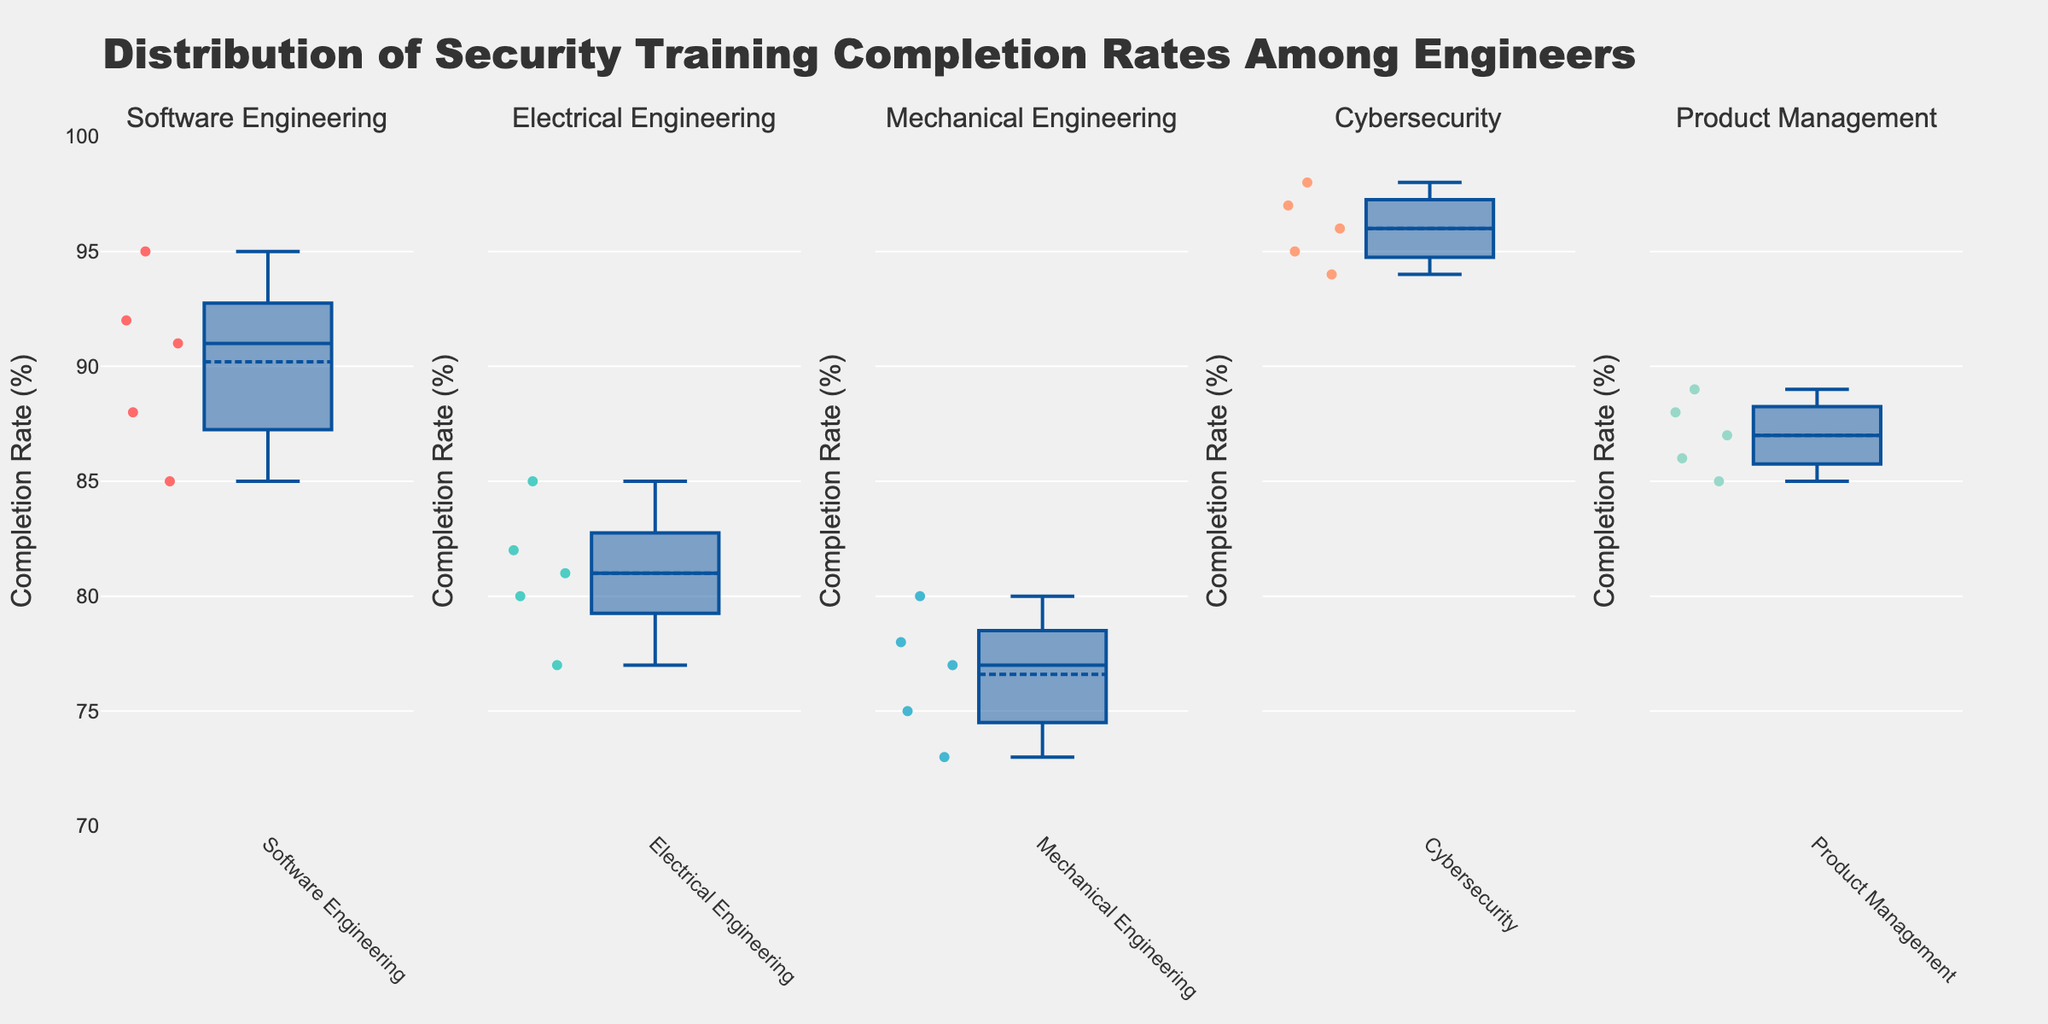What's the title of the plot? The title is displayed at the top of the figure and reads "Distribution of Security Training Completion Rates Among Engineers".
Answer: Distribution of Security Training Completion Rates Among Engineers What is the y-axis label? The y-axis label is located on the left side of the figure and it reads "Completion Rate (%)".
Answer: Completion Rate (%) How many departments are represented in the figure? There are 5 subplots, each representing a different department. The subplot titles are the department names.
Answer: 5 Which department has the highest median security training completion rate? The median value can be identified by the line inside the box of each subplot. The department with the highest median line is Cybersecurity.
Answer: Cybersecurity Which department shows the greatest variability in security training completion rates? Variability is indicated by the interquartile range (IQR), which is the distance between the top and bottom of the box. The department with the largest box is Mechanical Engineering.
Answer: Mechanical Engineering Compare the completion rates of Software Engineering and Electrical Engineering. Which department has a higher median completion rate? By looking at the line inside the boxes of Software Engineering and Electrical Engineering, the median in Software Engineering is higher.
Answer: Software Engineering Are there any departments where all engineers have completion rates above 80%? Looking at the lowest values in each subplot, only the Cybersecurity department has all its data points above 80%.
Answer: Cybersecurity What is the approximate range of completion rates in the Product Management department? The range can be determined by the lowest and highest points (whiskers) in the Product Management subplot. They range from about 85% to 89%.
Answer: 85% to 89% Which department has the lowest single security training completion rate? The lowest single rate can be spotted by finding the lowest point in any subplot. It appears in Mechanical Engineering with a rate of around 73%.
Answer: Mechanical Engineering Which department displays the most outliers in security training completion rates? Outliers are shown as individual points outside the whiskers. The Software Engineering department has the most outliers visible.
Answer: Software Engineering 